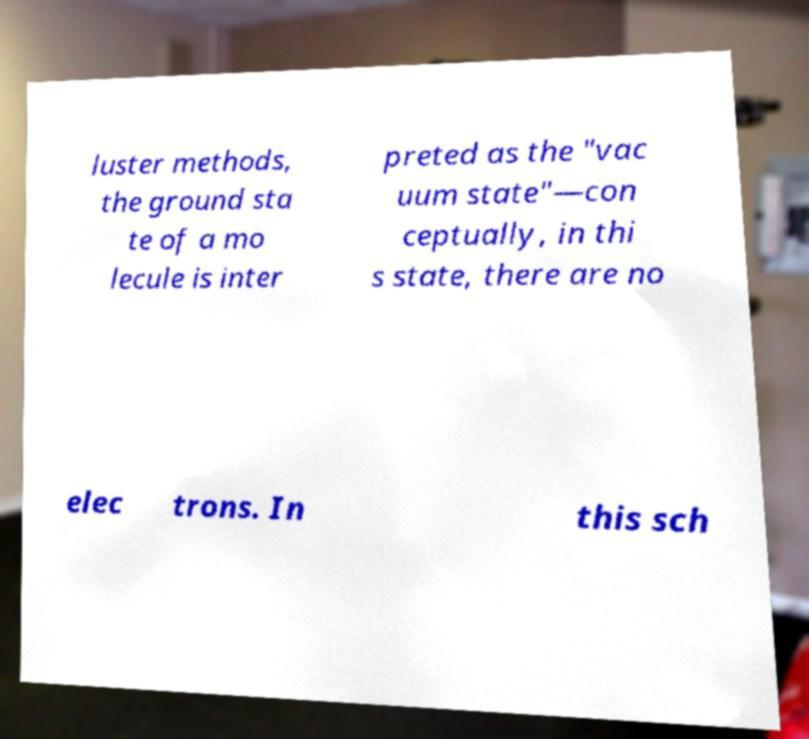Can you read and provide the text displayed in the image?This photo seems to have some interesting text. Can you extract and type it out for me? luster methods, the ground sta te of a mo lecule is inter preted as the "vac uum state"—con ceptually, in thi s state, there are no elec trons. In this sch 